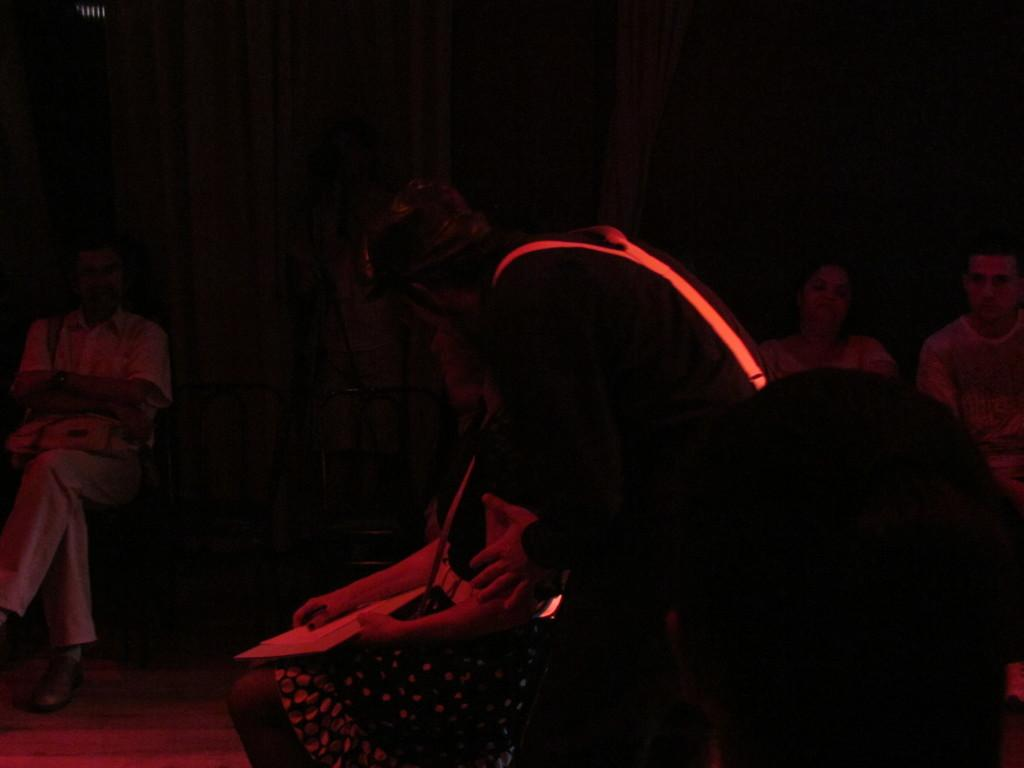How many people are in the image? There is a group of people in the image. What are the people doing in the image? The people are sitting on chairs. What structures can be seen in the image? There is a door and a wall in the image. Can you describe the lighting in the image? The image may have been taken during the night, which suggests that the lighting is dim or artificial. How many toes can be seen on the people in the image? There is no information about the people's toes in the image, so it cannot be determined. What type of field is visible in the image? There is no field present in the image; it features a group of people sitting on chairs, a door, and a wall. 